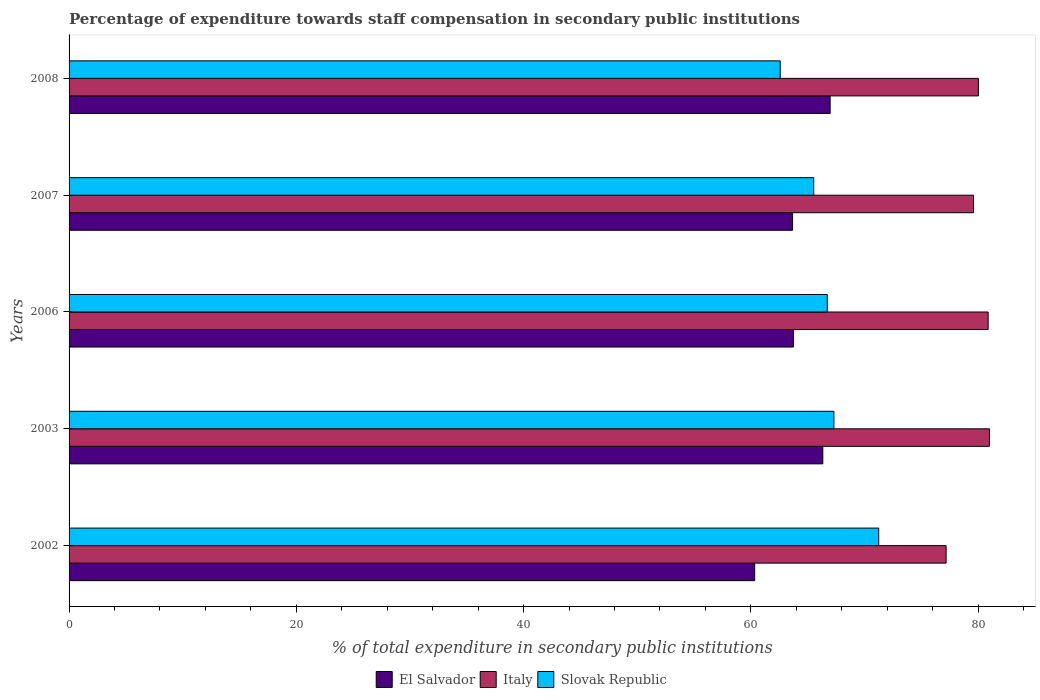How many different coloured bars are there?
Your response must be concise. 3. How many groups of bars are there?
Your answer should be very brief. 5. Are the number of bars per tick equal to the number of legend labels?
Provide a short and direct response. Yes. Are the number of bars on each tick of the Y-axis equal?
Your answer should be very brief. Yes. How many bars are there on the 2nd tick from the bottom?
Your answer should be very brief. 3. In how many cases, is the number of bars for a given year not equal to the number of legend labels?
Your answer should be compact. 0. What is the percentage of expenditure towards staff compensation in Slovak Republic in 2003?
Provide a short and direct response. 67.31. Across all years, what is the maximum percentage of expenditure towards staff compensation in El Salvador?
Your answer should be very brief. 66.98. Across all years, what is the minimum percentage of expenditure towards staff compensation in Italy?
Your answer should be compact. 77.19. In which year was the percentage of expenditure towards staff compensation in Italy minimum?
Ensure brevity in your answer.  2002. What is the total percentage of expenditure towards staff compensation in Slovak Republic in the graph?
Ensure brevity in your answer.  333.42. What is the difference between the percentage of expenditure towards staff compensation in Italy in 2002 and that in 2003?
Your response must be concise. -3.82. What is the difference between the percentage of expenditure towards staff compensation in Slovak Republic in 2007 and the percentage of expenditure towards staff compensation in El Salvador in 2002?
Make the answer very short. 5.2. What is the average percentage of expenditure towards staff compensation in El Salvador per year?
Provide a succinct answer. 64.22. In the year 2002, what is the difference between the percentage of expenditure towards staff compensation in Slovak Republic and percentage of expenditure towards staff compensation in El Salvador?
Make the answer very short. 10.92. In how many years, is the percentage of expenditure towards staff compensation in Italy greater than 40 %?
Offer a terse response. 5. What is the ratio of the percentage of expenditure towards staff compensation in Italy in 2006 to that in 2008?
Offer a terse response. 1.01. What is the difference between the highest and the second highest percentage of expenditure towards staff compensation in El Salvador?
Offer a terse response. 0.64. What is the difference between the highest and the lowest percentage of expenditure towards staff compensation in Slovak Republic?
Your answer should be very brief. 8.67. In how many years, is the percentage of expenditure towards staff compensation in El Salvador greater than the average percentage of expenditure towards staff compensation in El Salvador taken over all years?
Your answer should be very brief. 2. What does the 3rd bar from the bottom in 2002 represents?
Your answer should be compact. Slovak Republic. Are all the bars in the graph horizontal?
Your answer should be compact. Yes. How many years are there in the graph?
Offer a very short reply. 5. What is the difference between two consecutive major ticks on the X-axis?
Provide a succinct answer. 20. Are the values on the major ticks of X-axis written in scientific E-notation?
Keep it short and to the point. No. Does the graph contain any zero values?
Make the answer very short. No. How many legend labels are there?
Your answer should be compact. 3. What is the title of the graph?
Provide a short and direct response. Percentage of expenditure towards staff compensation in secondary public institutions. What is the label or title of the X-axis?
Your answer should be compact. % of total expenditure in secondary public institutions. What is the label or title of the Y-axis?
Provide a short and direct response. Years. What is the % of total expenditure in secondary public institutions in El Salvador in 2002?
Your answer should be compact. 60.34. What is the % of total expenditure in secondary public institutions in Italy in 2002?
Make the answer very short. 77.19. What is the % of total expenditure in secondary public institutions of Slovak Republic in 2002?
Keep it short and to the point. 71.26. What is the % of total expenditure in secondary public institutions in El Salvador in 2003?
Keep it short and to the point. 66.34. What is the % of total expenditure in secondary public institutions in Italy in 2003?
Your answer should be compact. 81. What is the % of total expenditure in secondary public institutions of Slovak Republic in 2003?
Provide a succinct answer. 67.31. What is the % of total expenditure in secondary public institutions of El Salvador in 2006?
Your answer should be very brief. 63.75. What is the % of total expenditure in secondary public institutions of Italy in 2006?
Offer a terse response. 80.89. What is the % of total expenditure in secondary public institutions of Slovak Republic in 2006?
Make the answer very short. 66.73. What is the % of total expenditure in secondary public institutions in El Salvador in 2007?
Offer a terse response. 63.67. What is the % of total expenditure in secondary public institutions of Italy in 2007?
Your answer should be compact. 79.6. What is the % of total expenditure in secondary public institutions of Slovak Republic in 2007?
Your answer should be very brief. 65.53. What is the % of total expenditure in secondary public institutions of El Salvador in 2008?
Your answer should be compact. 66.98. What is the % of total expenditure in secondary public institutions in Italy in 2008?
Ensure brevity in your answer.  80.03. What is the % of total expenditure in secondary public institutions in Slovak Republic in 2008?
Provide a short and direct response. 62.59. Across all years, what is the maximum % of total expenditure in secondary public institutions of El Salvador?
Give a very brief answer. 66.98. Across all years, what is the maximum % of total expenditure in secondary public institutions in Italy?
Offer a terse response. 81. Across all years, what is the maximum % of total expenditure in secondary public institutions of Slovak Republic?
Keep it short and to the point. 71.26. Across all years, what is the minimum % of total expenditure in secondary public institutions in El Salvador?
Your answer should be compact. 60.34. Across all years, what is the minimum % of total expenditure in secondary public institutions of Italy?
Keep it short and to the point. 77.19. Across all years, what is the minimum % of total expenditure in secondary public institutions of Slovak Republic?
Make the answer very short. 62.59. What is the total % of total expenditure in secondary public institutions of El Salvador in the graph?
Your answer should be compact. 321.08. What is the total % of total expenditure in secondary public institutions of Italy in the graph?
Your response must be concise. 398.7. What is the total % of total expenditure in secondary public institutions in Slovak Republic in the graph?
Provide a succinct answer. 333.42. What is the difference between the % of total expenditure in secondary public institutions in El Salvador in 2002 and that in 2003?
Make the answer very short. -6. What is the difference between the % of total expenditure in secondary public institutions of Italy in 2002 and that in 2003?
Keep it short and to the point. -3.82. What is the difference between the % of total expenditure in secondary public institutions in Slovak Republic in 2002 and that in 2003?
Make the answer very short. 3.94. What is the difference between the % of total expenditure in secondary public institutions in El Salvador in 2002 and that in 2006?
Provide a succinct answer. -3.41. What is the difference between the % of total expenditure in secondary public institutions of Italy in 2002 and that in 2006?
Provide a short and direct response. -3.7. What is the difference between the % of total expenditure in secondary public institutions in Slovak Republic in 2002 and that in 2006?
Give a very brief answer. 4.53. What is the difference between the % of total expenditure in secondary public institutions in El Salvador in 2002 and that in 2007?
Make the answer very short. -3.33. What is the difference between the % of total expenditure in secondary public institutions in Italy in 2002 and that in 2007?
Offer a terse response. -2.41. What is the difference between the % of total expenditure in secondary public institutions in Slovak Republic in 2002 and that in 2007?
Offer a very short reply. 5.72. What is the difference between the % of total expenditure in secondary public institutions in El Salvador in 2002 and that in 2008?
Provide a short and direct response. -6.64. What is the difference between the % of total expenditure in secondary public institutions in Italy in 2002 and that in 2008?
Make the answer very short. -2.84. What is the difference between the % of total expenditure in secondary public institutions in Slovak Republic in 2002 and that in 2008?
Give a very brief answer. 8.67. What is the difference between the % of total expenditure in secondary public institutions of El Salvador in 2003 and that in 2006?
Provide a succinct answer. 2.59. What is the difference between the % of total expenditure in secondary public institutions of Italy in 2003 and that in 2006?
Your answer should be very brief. 0.12. What is the difference between the % of total expenditure in secondary public institutions in Slovak Republic in 2003 and that in 2006?
Your answer should be compact. 0.58. What is the difference between the % of total expenditure in secondary public institutions of El Salvador in 2003 and that in 2007?
Your answer should be very brief. 2.66. What is the difference between the % of total expenditure in secondary public institutions in Italy in 2003 and that in 2007?
Make the answer very short. 1.4. What is the difference between the % of total expenditure in secondary public institutions in Slovak Republic in 2003 and that in 2007?
Keep it short and to the point. 1.78. What is the difference between the % of total expenditure in secondary public institutions of El Salvador in 2003 and that in 2008?
Ensure brevity in your answer.  -0.64. What is the difference between the % of total expenditure in secondary public institutions of Italy in 2003 and that in 2008?
Your answer should be very brief. 0.98. What is the difference between the % of total expenditure in secondary public institutions of Slovak Republic in 2003 and that in 2008?
Offer a terse response. 4.72. What is the difference between the % of total expenditure in secondary public institutions of El Salvador in 2006 and that in 2007?
Make the answer very short. 0.07. What is the difference between the % of total expenditure in secondary public institutions in Italy in 2006 and that in 2007?
Your response must be concise. 1.29. What is the difference between the % of total expenditure in secondary public institutions of Slovak Republic in 2006 and that in 2007?
Ensure brevity in your answer.  1.19. What is the difference between the % of total expenditure in secondary public institutions in El Salvador in 2006 and that in 2008?
Provide a succinct answer. -3.23. What is the difference between the % of total expenditure in secondary public institutions in Italy in 2006 and that in 2008?
Offer a very short reply. 0.86. What is the difference between the % of total expenditure in secondary public institutions of Slovak Republic in 2006 and that in 2008?
Provide a succinct answer. 4.14. What is the difference between the % of total expenditure in secondary public institutions in El Salvador in 2007 and that in 2008?
Your response must be concise. -3.3. What is the difference between the % of total expenditure in secondary public institutions of Italy in 2007 and that in 2008?
Provide a succinct answer. -0.43. What is the difference between the % of total expenditure in secondary public institutions of Slovak Republic in 2007 and that in 2008?
Provide a short and direct response. 2.95. What is the difference between the % of total expenditure in secondary public institutions of El Salvador in 2002 and the % of total expenditure in secondary public institutions of Italy in 2003?
Your response must be concise. -20.66. What is the difference between the % of total expenditure in secondary public institutions in El Salvador in 2002 and the % of total expenditure in secondary public institutions in Slovak Republic in 2003?
Make the answer very short. -6.97. What is the difference between the % of total expenditure in secondary public institutions in Italy in 2002 and the % of total expenditure in secondary public institutions in Slovak Republic in 2003?
Your response must be concise. 9.87. What is the difference between the % of total expenditure in secondary public institutions in El Salvador in 2002 and the % of total expenditure in secondary public institutions in Italy in 2006?
Make the answer very short. -20.55. What is the difference between the % of total expenditure in secondary public institutions of El Salvador in 2002 and the % of total expenditure in secondary public institutions of Slovak Republic in 2006?
Give a very brief answer. -6.39. What is the difference between the % of total expenditure in secondary public institutions in Italy in 2002 and the % of total expenditure in secondary public institutions in Slovak Republic in 2006?
Your answer should be compact. 10.46. What is the difference between the % of total expenditure in secondary public institutions in El Salvador in 2002 and the % of total expenditure in secondary public institutions in Italy in 2007?
Keep it short and to the point. -19.26. What is the difference between the % of total expenditure in secondary public institutions in El Salvador in 2002 and the % of total expenditure in secondary public institutions in Slovak Republic in 2007?
Your answer should be compact. -5.2. What is the difference between the % of total expenditure in secondary public institutions of Italy in 2002 and the % of total expenditure in secondary public institutions of Slovak Republic in 2007?
Ensure brevity in your answer.  11.65. What is the difference between the % of total expenditure in secondary public institutions of El Salvador in 2002 and the % of total expenditure in secondary public institutions of Italy in 2008?
Keep it short and to the point. -19.69. What is the difference between the % of total expenditure in secondary public institutions in El Salvador in 2002 and the % of total expenditure in secondary public institutions in Slovak Republic in 2008?
Offer a terse response. -2.25. What is the difference between the % of total expenditure in secondary public institutions in Italy in 2002 and the % of total expenditure in secondary public institutions in Slovak Republic in 2008?
Your response must be concise. 14.6. What is the difference between the % of total expenditure in secondary public institutions of El Salvador in 2003 and the % of total expenditure in secondary public institutions of Italy in 2006?
Offer a very short reply. -14.55. What is the difference between the % of total expenditure in secondary public institutions of El Salvador in 2003 and the % of total expenditure in secondary public institutions of Slovak Republic in 2006?
Ensure brevity in your answer.  -0.39. What is the difference between the % of total expenditure in secondary public institutions of Italy in 2003 and the % of total expenditure in secondary public institutions of Slovak Republic in 2006?
Provide a short and direct response. 14.27. What is the difference between the % of total expenditure in secondary public institutions in El Salvador in 2003 and the % of total expenditure in secondary public institutions in Italy in 2007?
Your response must be concise. -13.26. What is the difference between the % of total expenditure in secondary public institutions of El Salvador in 2003 and the % of total expenditure in secondary public institutions of Slovak Republic in 2007?
Provide a short and direct response. 0.8. What is the difference between the % of total expenditure in secondary public institutions in Italy in 2003 and the % of total expenditure in secondary public institutions in Slovak Republic in 2007?
Your answer should be very brief. 15.47. What is the difference between the % of total expenditure in secondary public institutions in El Salvador in 2003 and the % of total expenditure in secondary public institutions in Italy in 2008?
Give a very brief answer. -13.69. What is the difference between the % of total expenditure in secondary public institutions in El Salvador in 2003 and the % of total expenditure in secondary public institutions in Slovak Republic in 2008?
Ensure brevity in your answer.  3.75. What is the difference between the % of total expenditure in secondary public institutions of Italy in 2003 and the % of total expenditure in secondary public institutions of Slovak Republic in 2008?
Your answer should be compact. 18.41. What is the difference between the % of total expenditure in secondary public institutions in El Salvador in 2006 and the % of total expenditure in secondary public institutions in Italy in 2007?
Your answer should be compact. -15.85. What is the difference between the % of total expenditure in secondary public institutions in El Salvador in 2006 and the % of total expenditure in secondary public institutions in Slovak Republic in 2007?
Keep it short and to the point. -1.79. What is the difference between the % of total expenditure in secondary public institutions of Italy in 2006 and the % of total expenditure in secondary public institutions of Slovak Republic in 2007?
Offer a very short reply. 15.35. What is the difference between the % of total expenditure in secondary public institutions of El Salvador in 2006 and the % of total expenditure in secondary public institutions of Italy in 2008?
Make the answer very short. -16.28. What is the difference between the % of total expenditure in secondary public institutions in El Salvador in 2006 and the % of total expenditure in secondary public institutions in Slovak Republic in 2008?
Provide a succinct answer. 1.16. What is the difference between the % of total expenditure in secondary public institutions of Italy in 2006 and the % of total expenditure in secondary public institutions of Slovak Republic in 2008?
Your answer should be compact. 18.3. What is the difference between the % of total expenditure in secondary public institutions of El Salvador in 2007 and the % of total expenditure in secondary public institutions of Italy in 2008?
Provide a short and direct response. -16.35. What is the difference between the % of total expenditure in secondary public institutions in El Salvador in 2007 and the % of total expenditure in secondary public institutions in Slovak Republic in 2008?
Ensure brevity in your answer.  1.09. What is the difference between the % of total expenditure in secondary public institutions in Italy in 2007 and the % of total expenditure in secondary public institutions in Slovak Republic in 2008?
Offer a terse response. 17.01. What is the average % of total expenditure in secondary public institutions in El Salvador per year?
Provide a short and direct response. 64.22. What is the average % of total expenditure in secondary public institutions of Italy per year?
Provide a short and direct response. 79.74. What is the average % of total expenditure in secondary public institutions in Slovak Republic per year?
Offer a terse response. 66.68. In the year 2002, what is the difference between the % of total expenditure in secondary public institutions in El Salvador and % of total expenditure in secondary public institutions in Italy?
Your answer should be very brief. -16.85. In the year 2002, what is the difference between the % of total expenditure in secondary public institutions in El Salvador and % of total expenditure in secondary public institutions in Slovak Republic?
Your answer should be very brief. -10.92. In the year 2002, what is the difference between the % of total expenditure in secondary public institutions in Italy and % of total expenditure in secondary public institutions in Slovak Republic?
Provide a short and direct response. 5.93. In the year 2003, what is the difference between the % of total expenditure in secondary public institutions in El Salvador and % of total expenditure in secondary public institutions in Italy?
Give a very brief answer. -14.67. In the year 2003, what is the difference between the % of total expenditure in secondary public institutions in El Salvador and % of total expenditure in secondary public institutions in Slovak Republic?
Your answer should be compact. -0.98. In the year 2003, what is the difference between the % of total expenditure in secondary public institutions in Italy and % of total expenditure in secondary public institutions in Slovak Republic?
Make the answer very short. 13.69. In the year 2006, what is the difference between the % of total expenditure in secondary public institutions of El Salvador and % of total expenditure in secondary public institutions of Italy?
Provide a short and direct response. -17.14. In the year 2006, what is the difference between the % of total expenditure in secondary public institutions in El Salvador and % of total expenditure in secondary public institutions in Slovak Republic?
Provide a succinct answer. -2.98. In the year 2006, what is the difference between the % of total expenditure in secondary public institutions of Italy and % of total expenditure in secondary public institutions of Slovak Republic?
Your answer should be very brief. 14.16. In the year 2007, what is the difference between the % of total expenditure in secondary public institutions in El Salvador and % of total expenditure in secondary public institutions in Italy?
Your answer should be compact. -15.93. In the year 2007, what is the difference between the % of total expenditure in secondary public institutions in El Salvador and % of total expenditure in secondary public institutions in Slovak Republic?
Provide a succinct answer. -1.86. In the year 2007, what is the difference between the % of total expenditure in secondary public institutions in Italy and % of total expenditure in secondary public institutions in Slovak Republic?
Your answer should be compact. 14.06. In the year 2008, what is the difference between the % of total expenditure in secondary public institutions in El Salvador and % of total expenditure in secondary public institutions in Italy?
Your response must be concise. -13.05. In the year 2008, what is the difference between the % of total expenditure in secondary public institutions of El Salvador and % of total expenditure in secondary public institutions of Slovak Republic?
Provide a succinct answer. 4.39. In the year 2008, what is the difference between the % of total expenditure in secondary public institutions of Italy and % of total expenditure in secondary public institutions of Slovak Republic?
Offer a very short reply. 17.44. What is the ratio of the % of total expenditure in secondary public institutions in El Salvador in 2002 to that in 2003?
Offer a terse response. 0.91. What is the ratio of the % of total expenditure in secondary public institutions of Italy in 2002 to that in 2003?
Your answer should be compact. 0.95. What is the ratio of the % of total expenditure in secondary public institutions of Slovak Republic in 2002 to that in 2003?
Provide a succinct answer. 1.06. What is the ratio of the % of total expenditure in secondary public institutions of El Salvador in 2002 to that in 2006?
Make the answer very short. 0.95. What is the ratio of the % of total expenditure in secondary public institutions in Italy in 2002 to that in 2006?
Ensure brevity in your answer.  0.95. What is the ratio of the % of total expenditure in secondary public institutions in Slovak Republic in 2002 to that in 2006?
Provide a succinct answer. 1.07. What is the ratio of the % of total expenditure in secondary public institutions of El Salvador in 2002 to that in 2007?
Make the answer very short. 0.95. What is the ratio of the % of total expenditure in secondary public institutions in Italy in 2002 to that in 2007?
Your answer should be very brief. 0.97. What is the ratio of the % of total expenditure in secondary public institutions of Slovak Republic in 2002 to that in 2007?
Your answer should be compact. 1.09. What is the ratio of the % of total expenditure in secondary public institutions of El Salvador in 2002 to that in 2008?
Give a very brief answer. 0.9. What is the ratio of the % of total expenditure in secondary public institutions of Italy in 2002 to that in 2008?
Offer a terse response. 0.96. What is the ratio of the % of total expenditure in secondary public institutions in Slovak Republic in 2002 to that in 2008?
Give a very brief answer. 1.14. What is the ratio of the % of total expenditure in secondary public institutions of El Salvador in 2003 to that in 2006?
Keep it short and to the point. 1.04. What is the ratio of the % of total expenditure in secondary public institutions in Italy in 2003 to that in 2006?
Give a very brief answer. 1. What is the ratio of the % of total expenditure in secondary public institutions of Slovak Republic in 2003 to that in 2006?
Make the answer very short. 1.01. What is the ratio of the % of total expenditure in secondary public institutions of El Salvador in 2003 to that in 2007?
Make the answer very short. 1.04. What is the ratio of the % of total expenditure in secondary public institutions of Italy in 2003 to that in 2007?
Give a very brief answer. 1.02. What is the ratio of the % of total expenditure in secondary public institutions in Slovak Republic in 2003 to that in 2007?
Your answer should be very brief. 1.03. What is the ratio of the % of total expenditure in secondary public institutions in El Salvador in 2003 to that in 2008?
Ensure brevity in your answer.  0.99. What is the ratio of the % of total expenditure in secondary public institutions of Italy in 2003 to that in 2008?
Provide a short and direct response. 1.01. What is the ratio of the % of total expenditure in secondary public institutions of Slovak Republic in 2003 to that in 2008?
Make the answer very short. 1.08. What is the ratio of the % of total expenditure in secondary public institutions in Italy in 2006 to that in 2007?
Provide a succinct answer. 1.02. What is the ratio of the % of total expenditure in secondary public institutions of Slovak Republic in 2006 to that in 2007?
Your answer should be compact. 1.02. What is the ratio of the % of total expenditure in secondary public institutions in El Salvador in 2006 to that in 2008?
Make the answer very short. 0.95. What is the ratio of the % of total expenditure in secondary public institutions in Italy in 2006 to that in 2008?
Keep it short and to the point. 1.01. What is the ratio of the % of total expenditure in secondary public institutions of Slovak Republic in 2006 to that in 2008?
Make the answer very short. 1.07. What is the ratio of the % of total expenditure in secondary public institutions of El Salvador in 2007 to that in 2008?
Offer a very short reply. 0.95. What is the ratio of the % of total expenditure in secondary public institutions of Slovak Republic in 2007 to that in 2008?
Your answer should be very brief. 1.05. What is the difference between the highest and the second highest % of total expenditure in secondary public institutions of El Salvador?
Provide a short and direct response. 0.64. What is the difference between the highest and the second highest % of total expenditure in secondary public institutions in Italy?
Your answer should be very brief. 0.12. What is the difference between the highest and the second highest % of total expenditure in secondary public institutions of Slovak Republic?
Keep it short and to the point. 3.94. What is the difference between the highest and the lowest % of total expenditure in secondary public institutions of El Salvador?
Your answer should be compact. 6.64. What is the difference between the highest and the lowest % of total expenditure in secondary public institutions of Italy?
Provide a short and direct response. 3.82. What is the difference between the highest and the lowest % of total expenditure in secondary public institutions of Slovak Republic?
Give a very brief answer. 8.67. 